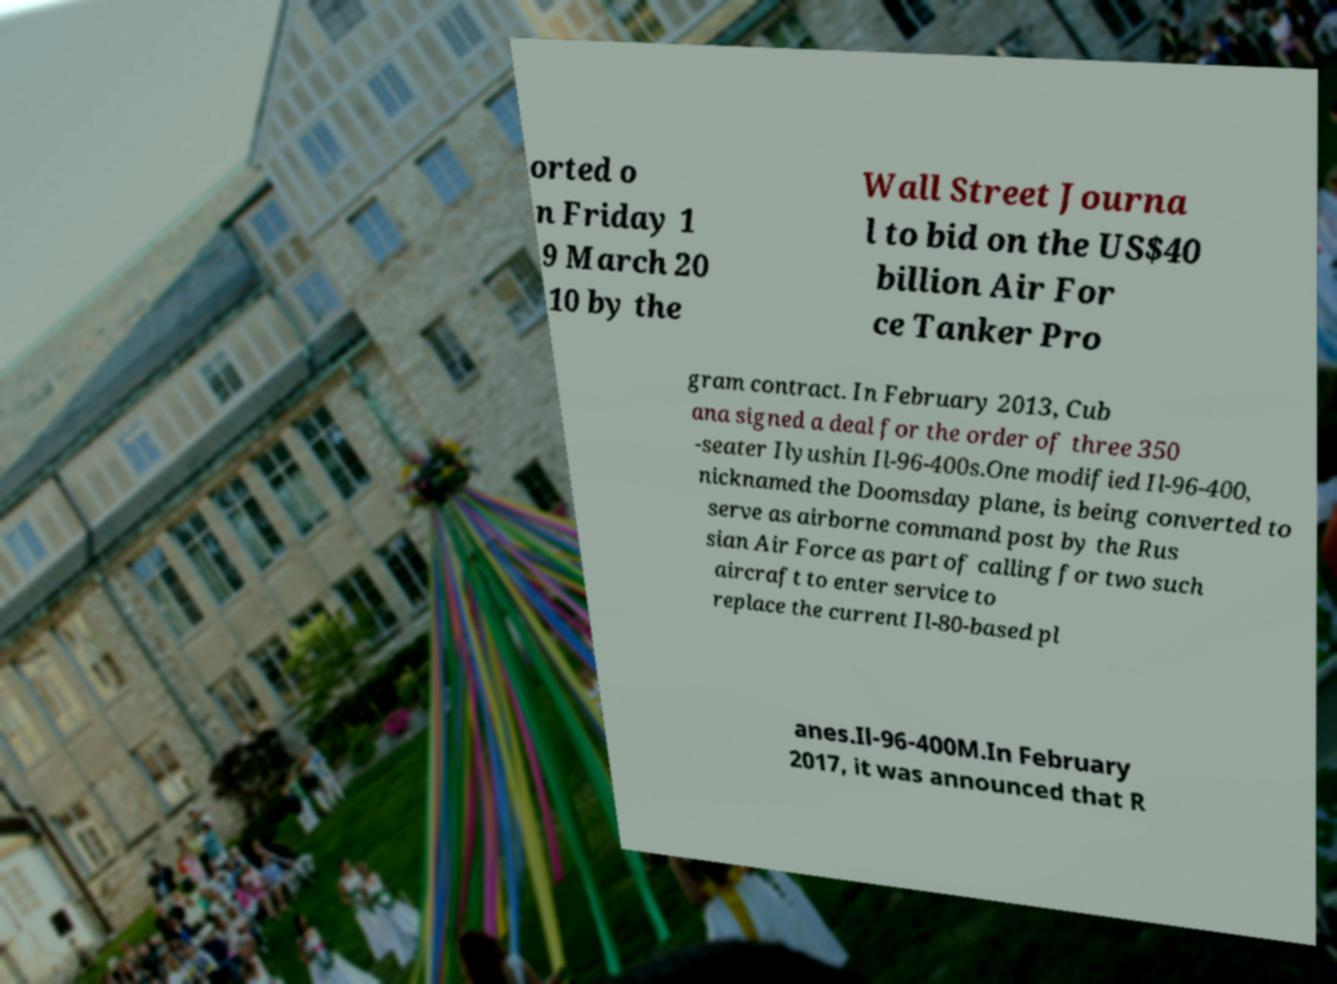Please read and relay the text visible in this image. What does it say? orted o n Friday 1 9 March 20 10 by the Wall Street Journa l to bid on the US$40 billion Air For ce Tanker Pro gram contract. In February 2013, Cub ana signed a deal for the order of three 350 -seater Ilyushin Il-96-400s.One modified Il-96-400, nicknamed the Doomsday plane, is being converted to serve as airborne command post by the Rus sian Air Force as part of calling for two such aircraft to enter service to replace the current Il-80-based pl anes.Il-96-400M.In February 2017, it was announced that R 